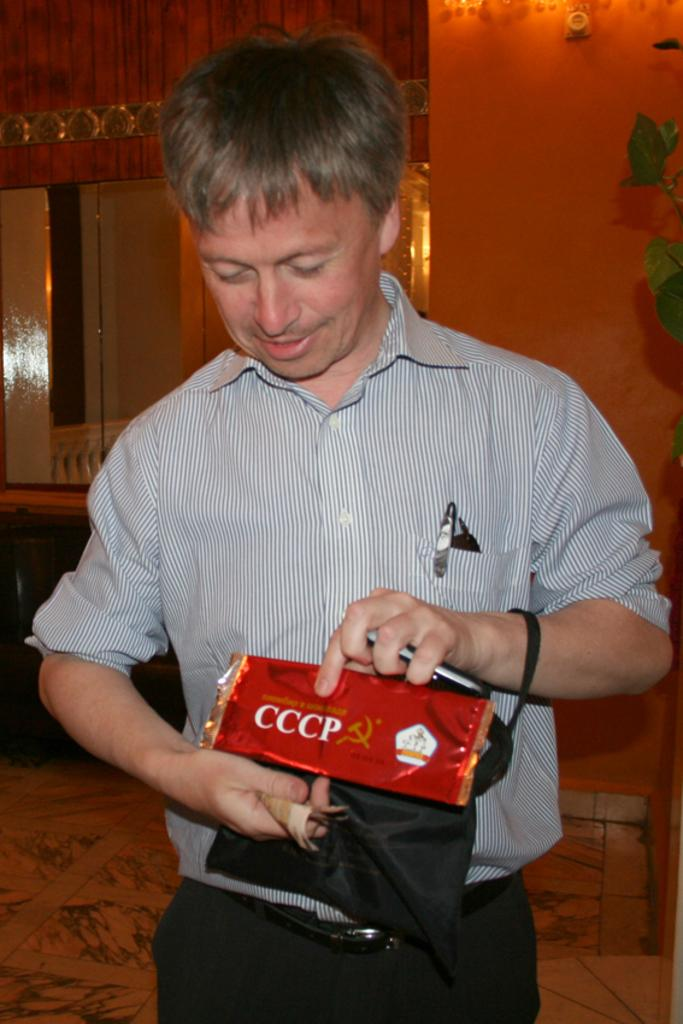What is the man in the image holding? The man is holding a packet, a bag, a mobile, and money in the image. Can you describe the background of the image? There is a wall, mirrors, a houseplant, and other objects in the background of the image. What is the man's desire for the future, as depicted in the image? There is no information about the man's desires or future plans in the image. 